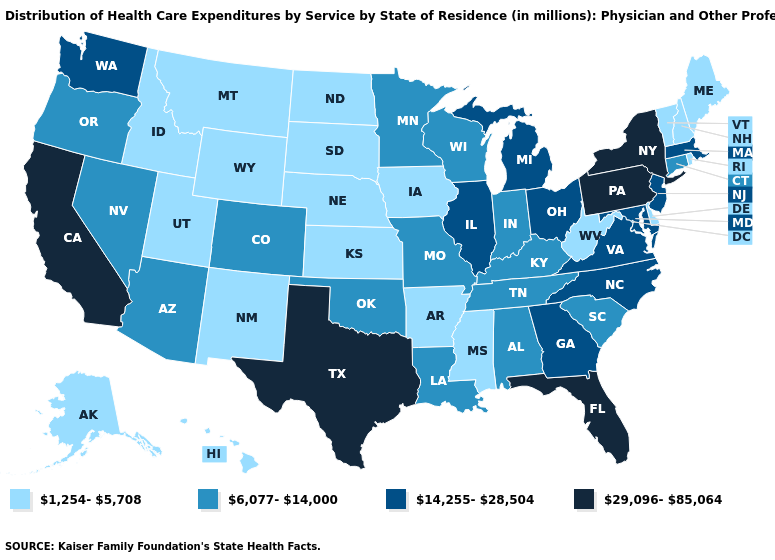What is the highest value in states that border Colorado?
Quick response, please. 6,077-14,000. Does New Jersey have the highest value in the Northeast?
Concise answer only. No. What is the lowest value in the MidWest?
Answer briefly. 1,254-5,708. Does the map have missing data?
Answer briefly. No. What is the highest value in the South ?
Short answer required. 29,096-85,064. What is the highest value in the USA?
Concise answer only. 29,096-85,064. What is the highest value in the USA?
Concise answer only. 29,096-85,064. Name the states that have a value in the range 14,255-28,504?
Be succinct. Georgia, Illinois, Maryland, Massachusetts, Michigan, New Jersey, North Carolina, Ohio, Virginia, Washington. Does the map have missing data?
Answer briefly. No. Does the first symbol in the legend represent the smallest category?
Answer briefly. Yes. Does Montana have the lowest value in the West?
Short answer required. Yes. What is the highest value in states that border New York?
Short answer required. 29,096-85,064. What is the value of New York?
Answer briefly. 29,096-85,064. Among the states that border Nebraska , which have the highest value?
Keep it brief. Colorado, Missouri. 